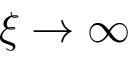Convert formula to latex. <formula><loc_0><loc_0><loc_500><loc_500>\xi \rightarrow \infty</formula> 